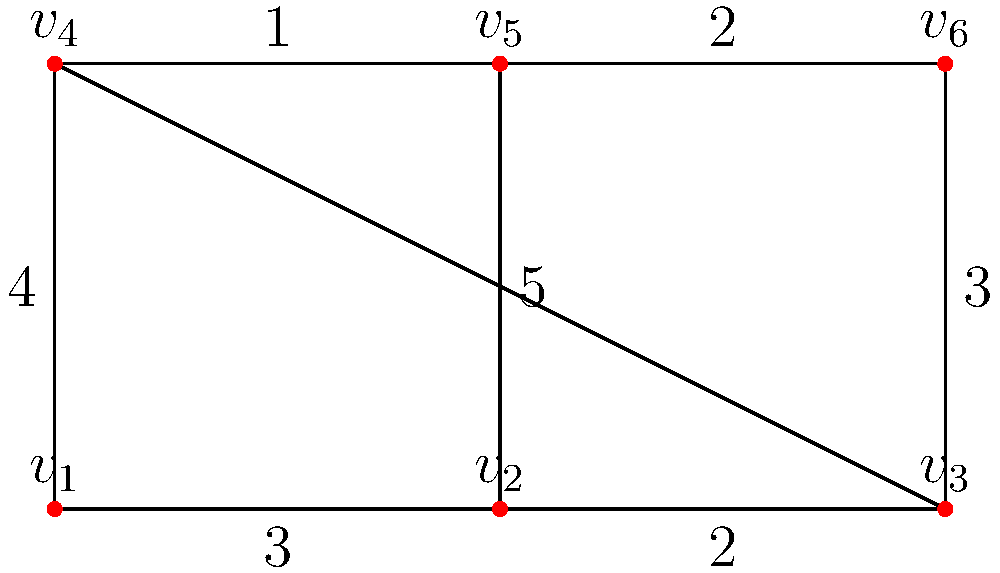You're arranging bookshelves in your child's room, represented by the graph above. Each vertex represents a possible bookshelf location, and the edges represent the paths between them. The weights on the edges indicate the difficulty of moving between locations (higher numbers mean more difficulty). What is the minimum total difficulty to visit all locations exactly once, starting and ending at $v_1$? To solve this problem, we need to find the Hamiltonian cycle with the minimum total weight. Let's approach this step-by-step:

1) First, list all possible Hamiltonian cycles starting and ending at $v_1$:
   
   a) $v_1 - v_2 - v_3 - v_6 - v_5 - v_4 - v_1$
   b) $v_1 - v_2 - v_5 - v_6 - v_3 - v_4 - v_1$
   c) $v_1 - v_4 - v_5 - v_2 - v_3 - v_6 - v_1$
   d) $v_1 - v_4 - v_5 - v_6 - v_3 - v_2 - v_1$

2) Now, calculate the total weight for each cycle:

   a) $3 + 2 + 3 + 2 + 5 + 4 = 19$
   b) $3 + 5 + 2 + 2 + 4 + 4 = 20$
   c) $4 + 1 + 5 + 2 + 3 + 3 = 18$
   d) $4 + 1 + 2 + 2 + 3 + 3 = 15$

3) The minimum total weight is 15, corresponding to the path $v_1 - v_4 - v_5 - v_6 - v_3 - v_2 - v_1$.

This solution represents the optimal arrangement strategy, allowing you to efficiently set up all bookshelves while minimizing the difficulty of movement between locations.
Answer: 15 